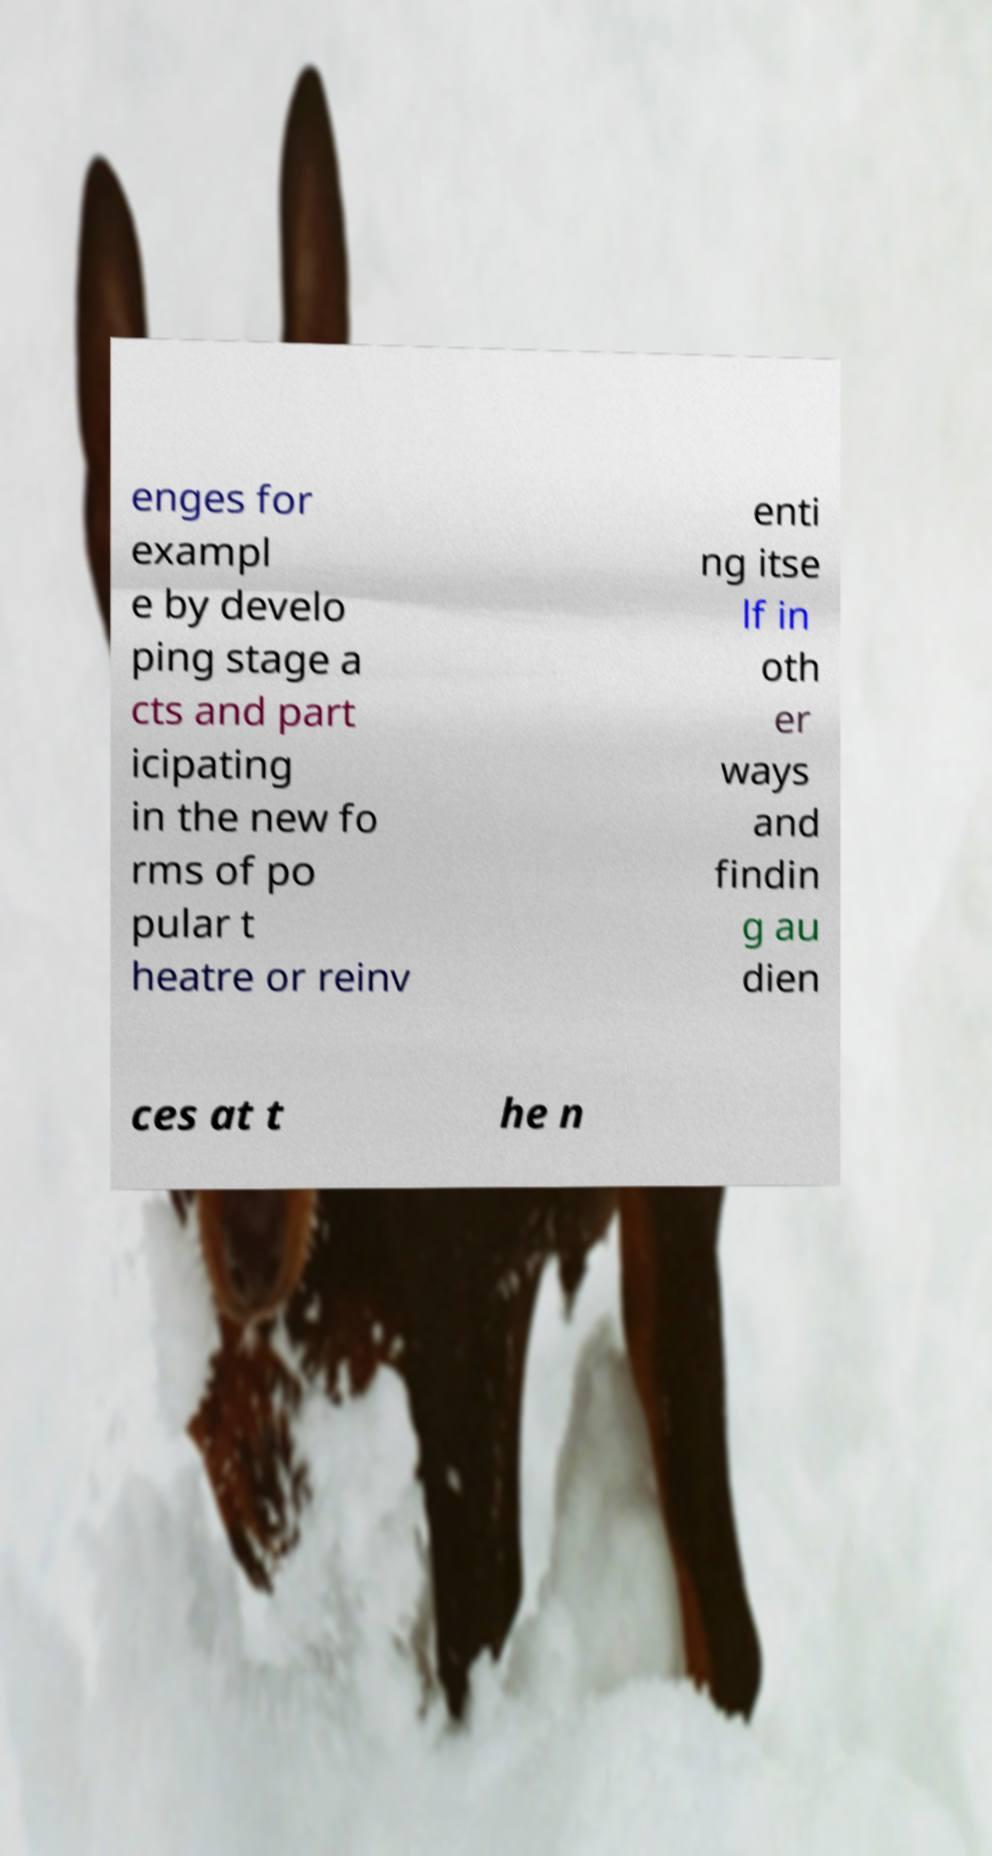There's text embedded in this image that I need extracted. Can you transcribe it verbatim? enges for exampl e by develo ping stage a cts and part icipating in the new fo rms of po pular t heatre or reinv enti ng itse lf in oth er ways and findin g au dien ces at t he n 